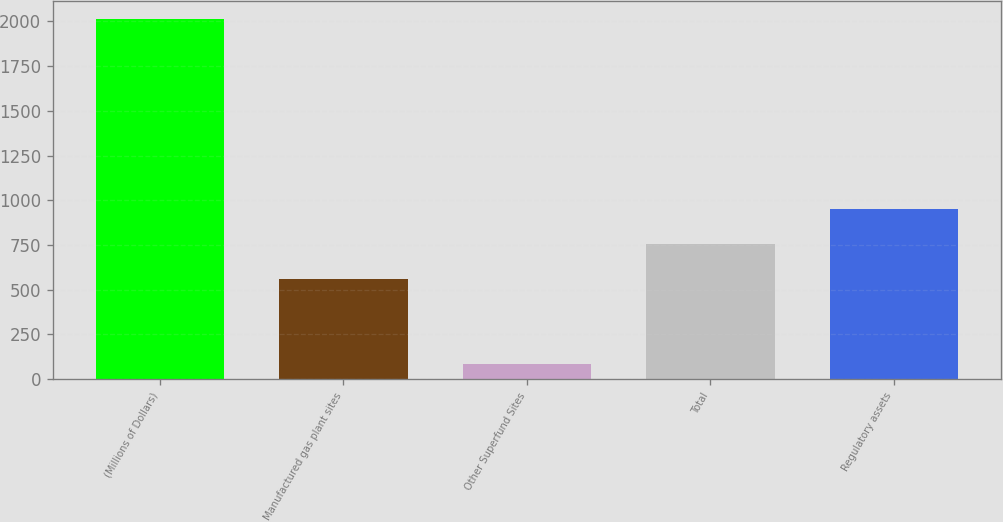Convert chart to OTSL. <chart><loc_0><loc_0><loc_500><loc_500><bar_chart><fcel>(Millions of Dollars)<fcel>Manufactured gas plant sites<fcel>Other Superfund Sites<fcel>Total<fcel>Regulatory assets<nl><fcel>2013<fcel>562<fcel>82<fcel>755.1<fcel>948.2<nl></chart> 